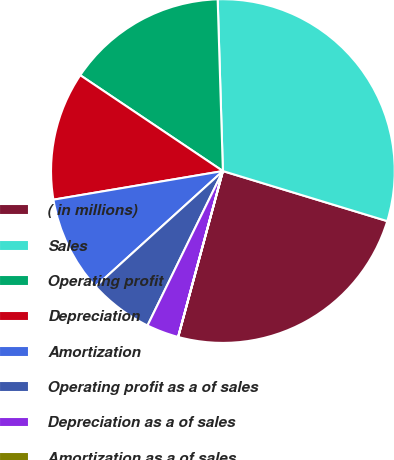Convert chart. <chart><loc_0><loc_0><loc_500><loc_500><pie_chart><fcel>( in millions)<fcel>Sales<fcel>Operating profit<fcel>Depreciation<fcel>Amortization<fcel>Operating profit as a of sales<fcel>Depreciation as a of sales<fcel>Amortization as a of sales<nl><fcel>24.48%<fcel>30.19%<fcel>15.1%<fcel>12.08%<fcel>9.06%<fcel>6.05%<fcel>3.03%<fcel>0.01%<nl></chart> 